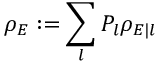<formula> <loc_0><loc_0><loc_500><loc_500>\rho _ { E } \colon = \sum _ { l } P _ { l } \rho _ { E | l }</formula> 